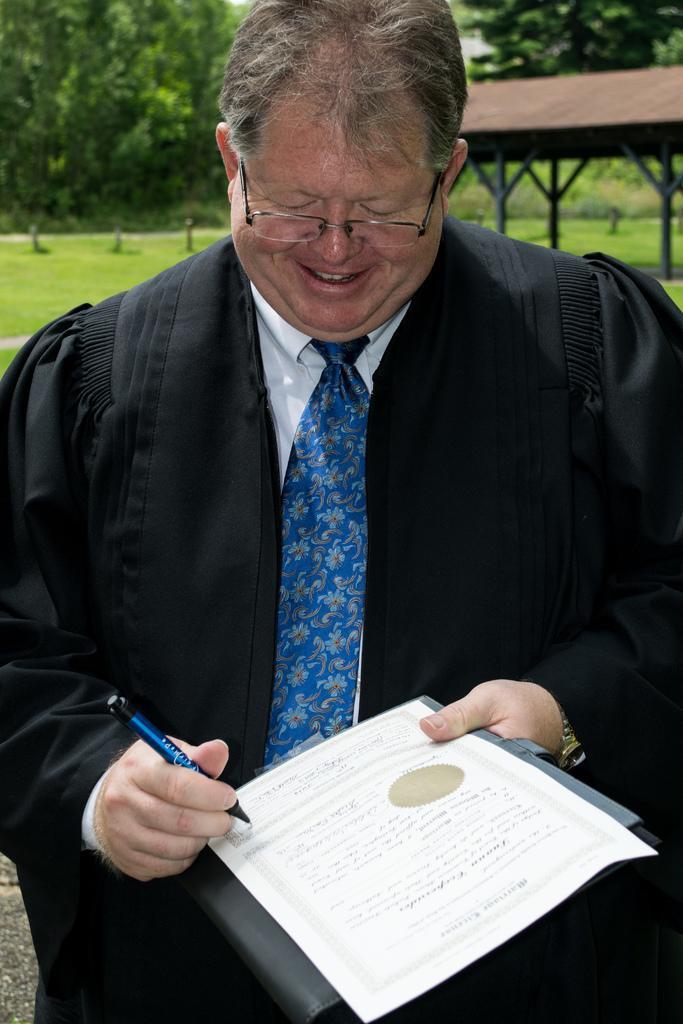In one or two sentences, can you explain what this image depicts? In this image, we can see there is a person in the black color coat, holding a document with a hand, holding a pen with other hand and writing on the document. And he is smiling. In the background, there is a shelter, there are trees and grass on the ground. 